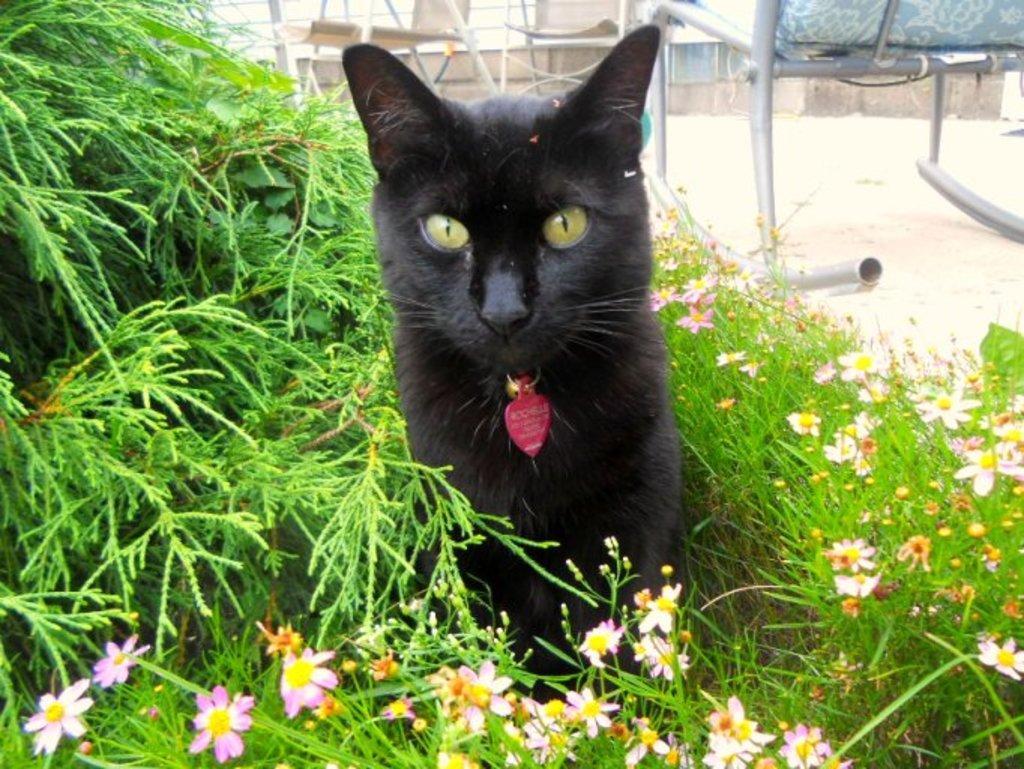How would you summarize this image in a sentence or two? In this image I can see a black cat is sitting in the flower plants. 